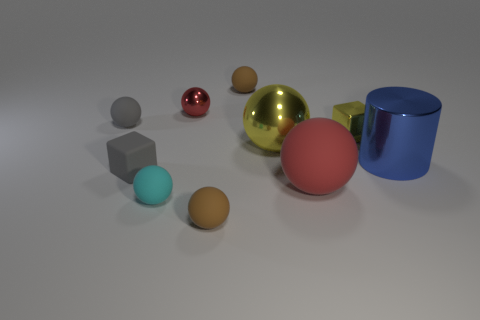Subtract all brown cylinders. How many brown balls are left? 2 Subtract all tiny cyan balls. How many balls are left? 6 Subtract 4 balls. How many balls are left? 3 Subtract all red balls. How many balls are left? 5 Subtract all green spheres. Subtract all yellow cubes. How many spheres are left? 7 Subtract all cylinders. How many objects are left? 9 Subtract all big red balls. Subtract all blue metallic things. How many objects are left? 8 Add 1 small things. How many small things are left? 8 Add 3 yellow shiny things. How many yellow shiny things exist? 5 Subtract 0 red cylinders. How many objects are left? 10 